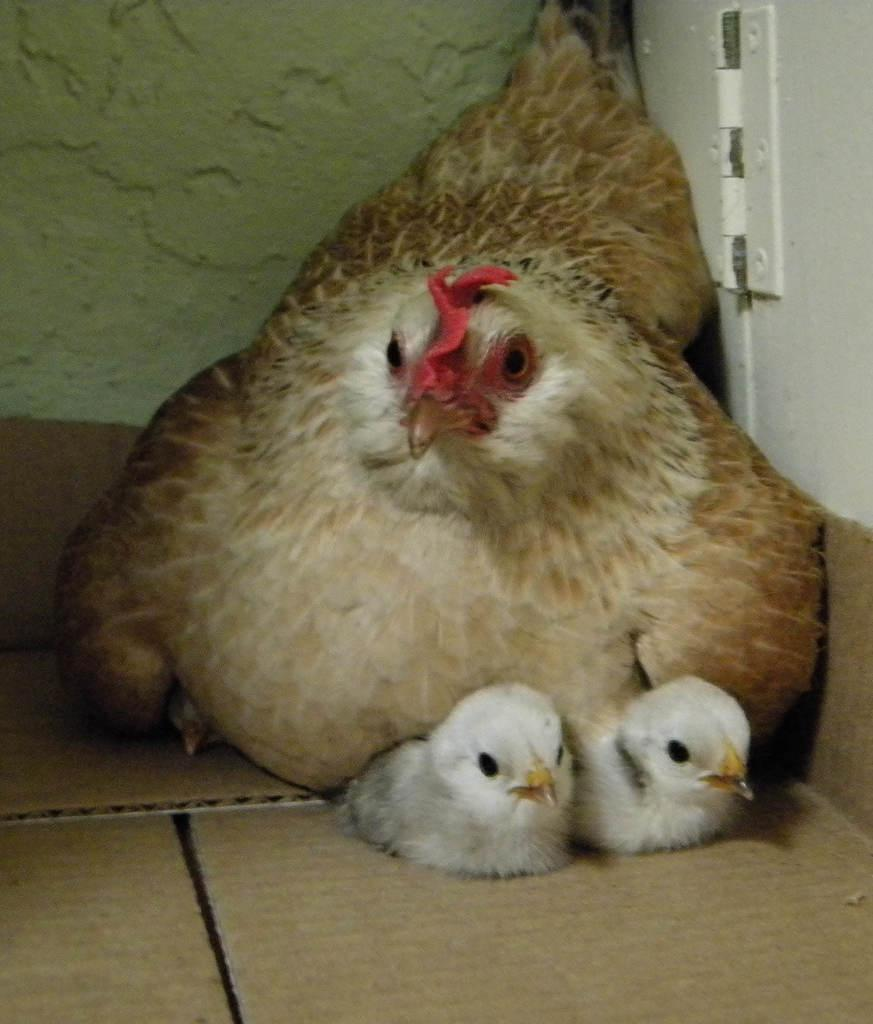What type of animal can be seen in the image? There is a hen in the image. Are there any baby animals with the hen? Yes, there are chicks in the image. What are the hen and chicks resting on? The hen and chicks are on cardboard sheets. What can be seen in the background of the image? There is a wall in the image. What type of yam is being used as a toy for the chicks in the image? There is no yam present in the image, and the chicks are not shown playing with any toys. What is the limit of the wall in the image? The wall in the image does not have a limit mentioned, and we cannot determine its extent from the provided facts. 